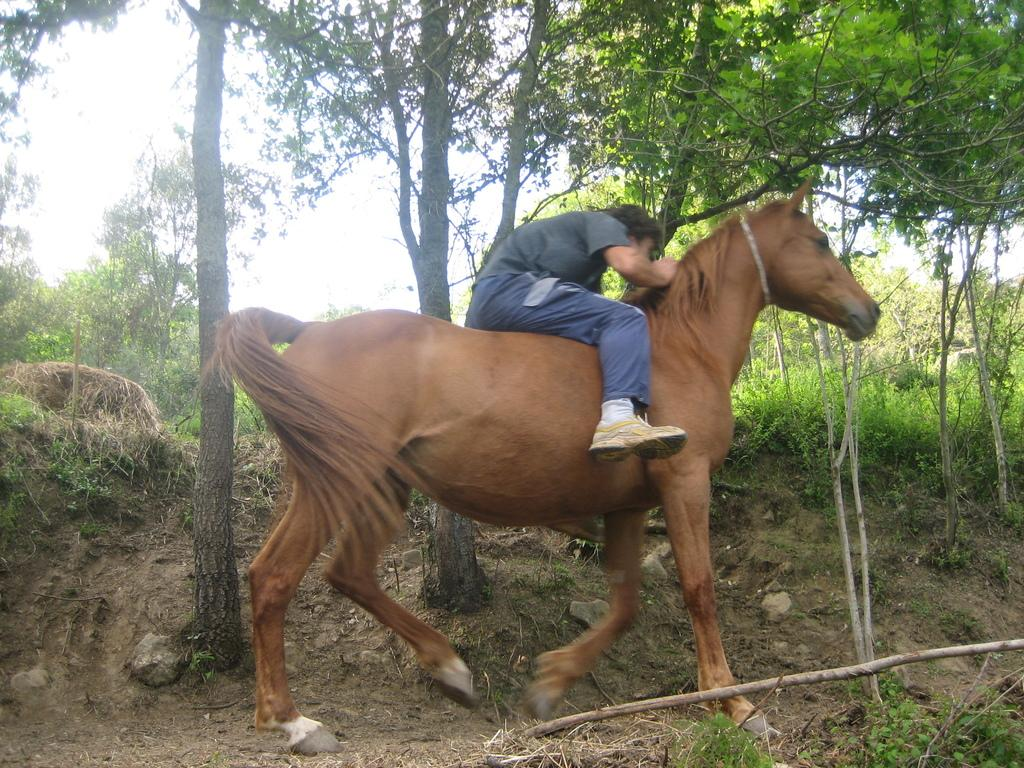What is the man in the image wearing? The man is wearing a blue t-shirt in the image. What is the man doing in the image? The man is riding a horse in the image. What type of environment can be seen in the image? There are trees visible in the image, which might suggest that it was taken in a forest. What type of key is the man holding while riding the horse in the image? There is no key present in the image; the man is riding a horse while wearing a blue t-shirt. 